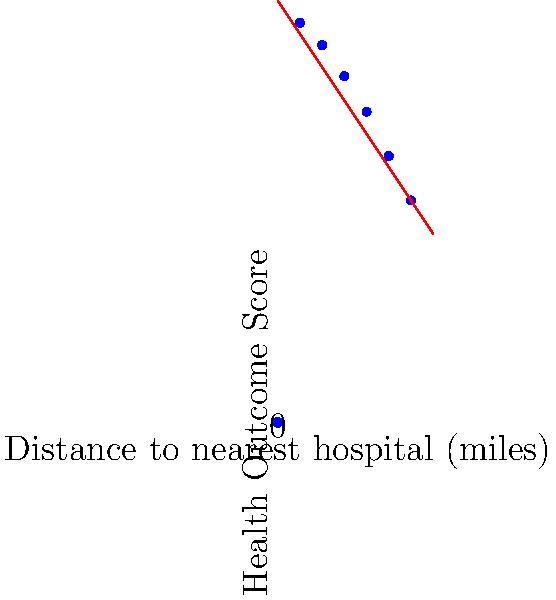Based on the infographic, what is the approximate decrease in Health Outcome Score for every 10-mile increase in distance to the nearest hospital? To answer this question, we need to analyze the trend shown in the infographic:

1. Observe that there is a clear negative correlation between distance to the nearest hospital and health outcome score.

2. To calculate the approximate decrease in Health Outcome Score for every 10-mile increase, we can:
   a. Choose two points on the trend line that are 10 miles apart.
   b. Calculate the difference in Health Outcome Score between these points.

3. Let's choose the points at 10 miles and 20 miles:
   - At 10 miles, the Health Outcome Score is approximately 85.
   - At 20 miles, the Health Outcome Score is approximately 70.

4. Calculate the difference:
   $85 - 70 = 15$

5. Therefore, for every 10-mile increase in distance, the Health Outcome Score decreases by approximately 15 points.

This linear trend appears consistent across the graph, so we can generalize this observation to the entire range of distances shown.
Answer: 15 points 